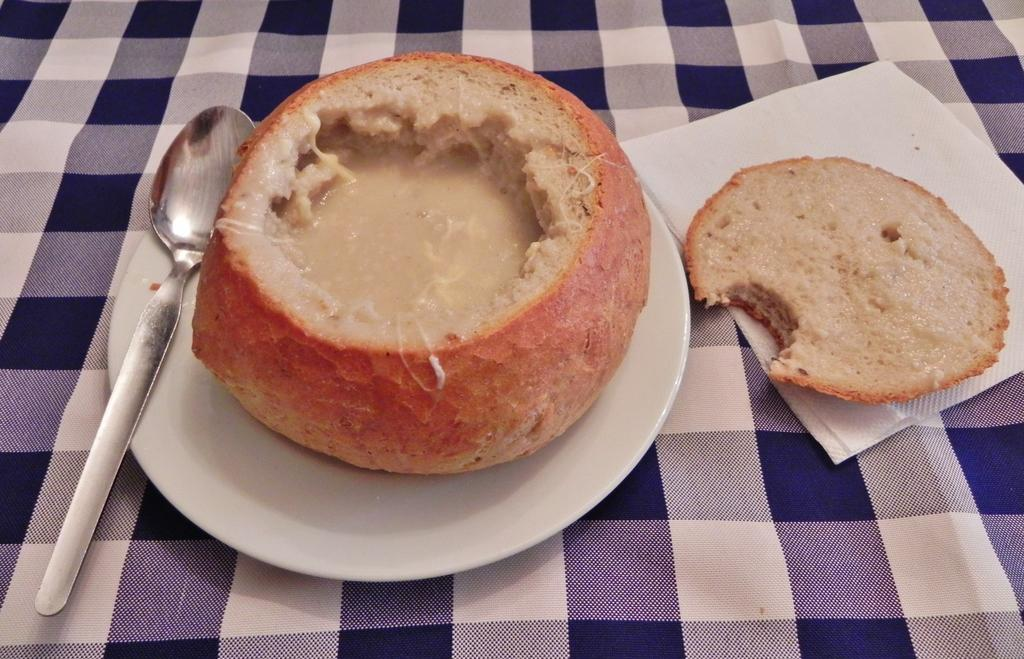What is on the plate in the image? There are food items on a plate in the image. What is used for wiping or cleaning in the image? There is a paper napkin in the image. What utensil is present in the image? There is a spoon in the image. Where is the spoon located in the image? The spoon is on a cloth in the image. What type of harmony is being played in the background of the image? There is no music or harmony present in the image; it only features food items, a paper napkin, a spoon, and a cloth. Can you see a chain attached to the spoon in the image? There is no chain attached to the spoon in the image. 